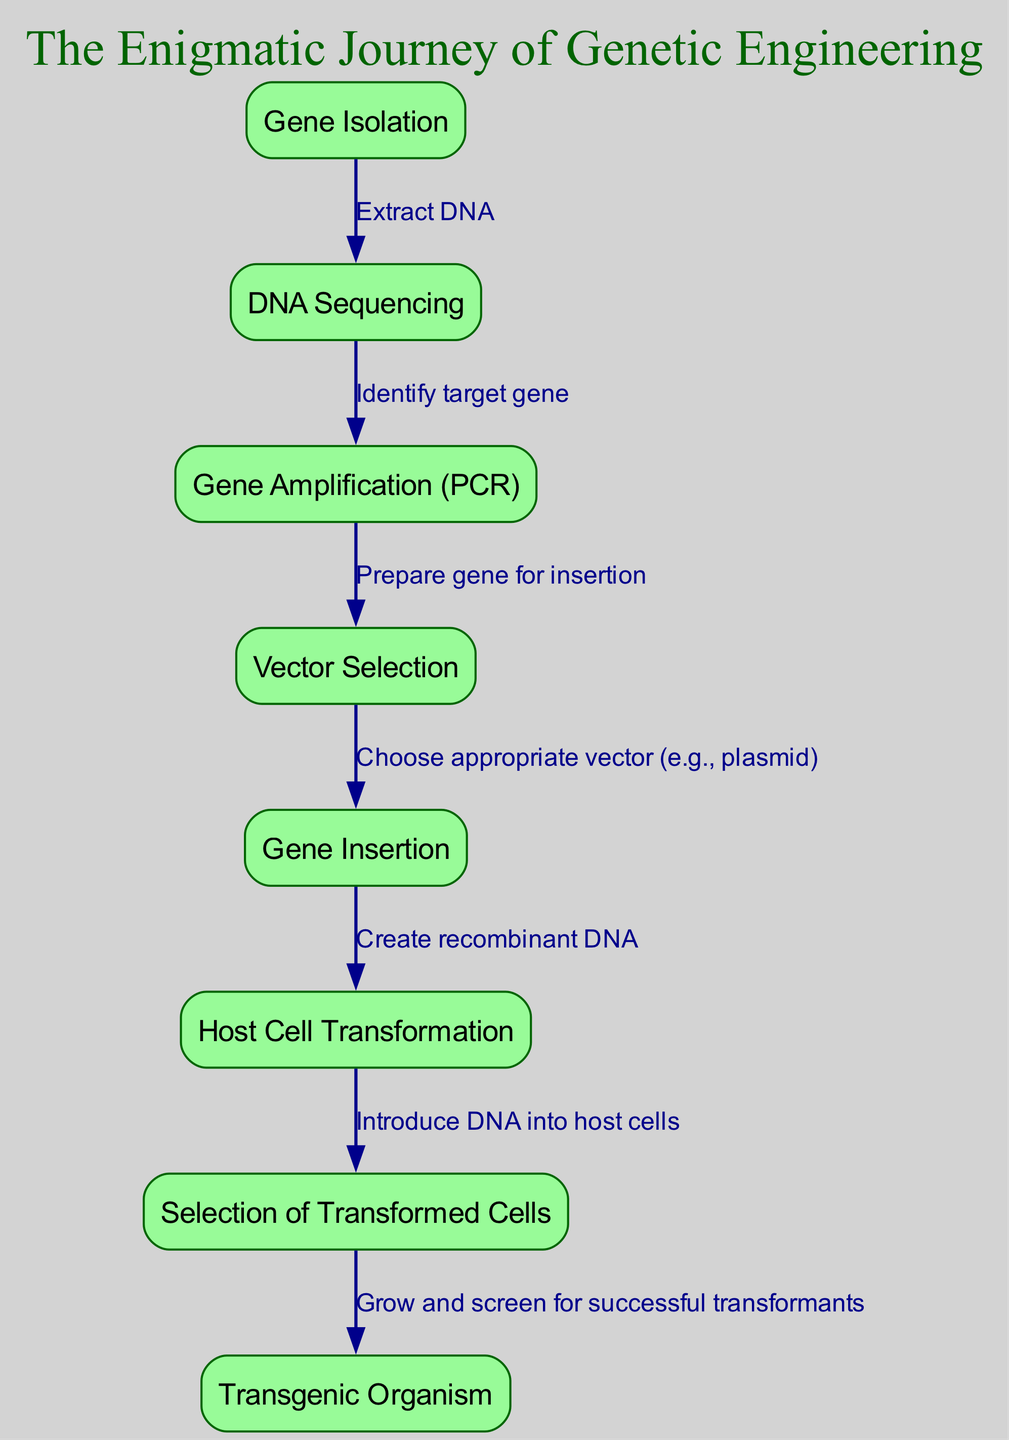What is the first step in the flowchart? The first step in the flowchart is represented by the node labeled "Gene Isolation". This node indicates the starting point for the process of genetic engineering.
Answer: Gene Isolation How many edges are there in the flowchart? By counting each connection from one step to the next, we find that there are a total of 7 edges linking the various nodes in the flowchart.
Answer: 7 What is the final outcome of this genetic engineering process? The final node in the flowchart represents the outcome of the entire process, which is labeled "Transgenic Organism". This signifies the successful creation of an organism with inserted genes.
Answer: Transgenic Organism Which step follows DNA Sequencing? Following the node labeled "DNA Sequencing", the next step in the flowchart is "Gene Amplification (PCR)", which indicates the continuation of the process after identifying the target gene.
Answer: Gene Amplification (PCR) What connection is made from "Host Cell Transformation" to its following node? The connection from "Host Cell Transformation" leads to the node labeled "Selection of Transformed Cells", indicating the process of identifying which host cells have successfully incorporated the new genetic material.
Answer: Selection of Transformed Cells How does "Vector Selection" relate to its prior step? "Vector Selection" follows "Gene Amplification (PCR)" in the flowchart, indicating that after the gene is amplified, a suitable vector is chosen for gene insertion.
Answer: Precedes Gene Insertion Name the relationship between "Gene Insertion" and "Host Cell Transformation". The edge connecting "Gene Insertion" to "Host Cell Transformation" shows that after the gene is inserted into the vector, the next step is to introduce this recombinant DNA into the host cells.
Answer: Create recombinant DNA What is the purpose of the "Selection of Transformed Cells" step? The purpose of this step is to identify and select those cells that have successfully integrated the recombinant DNA, which is crucial for producing viable transgenic organisms.
Answer: Successful transformants 